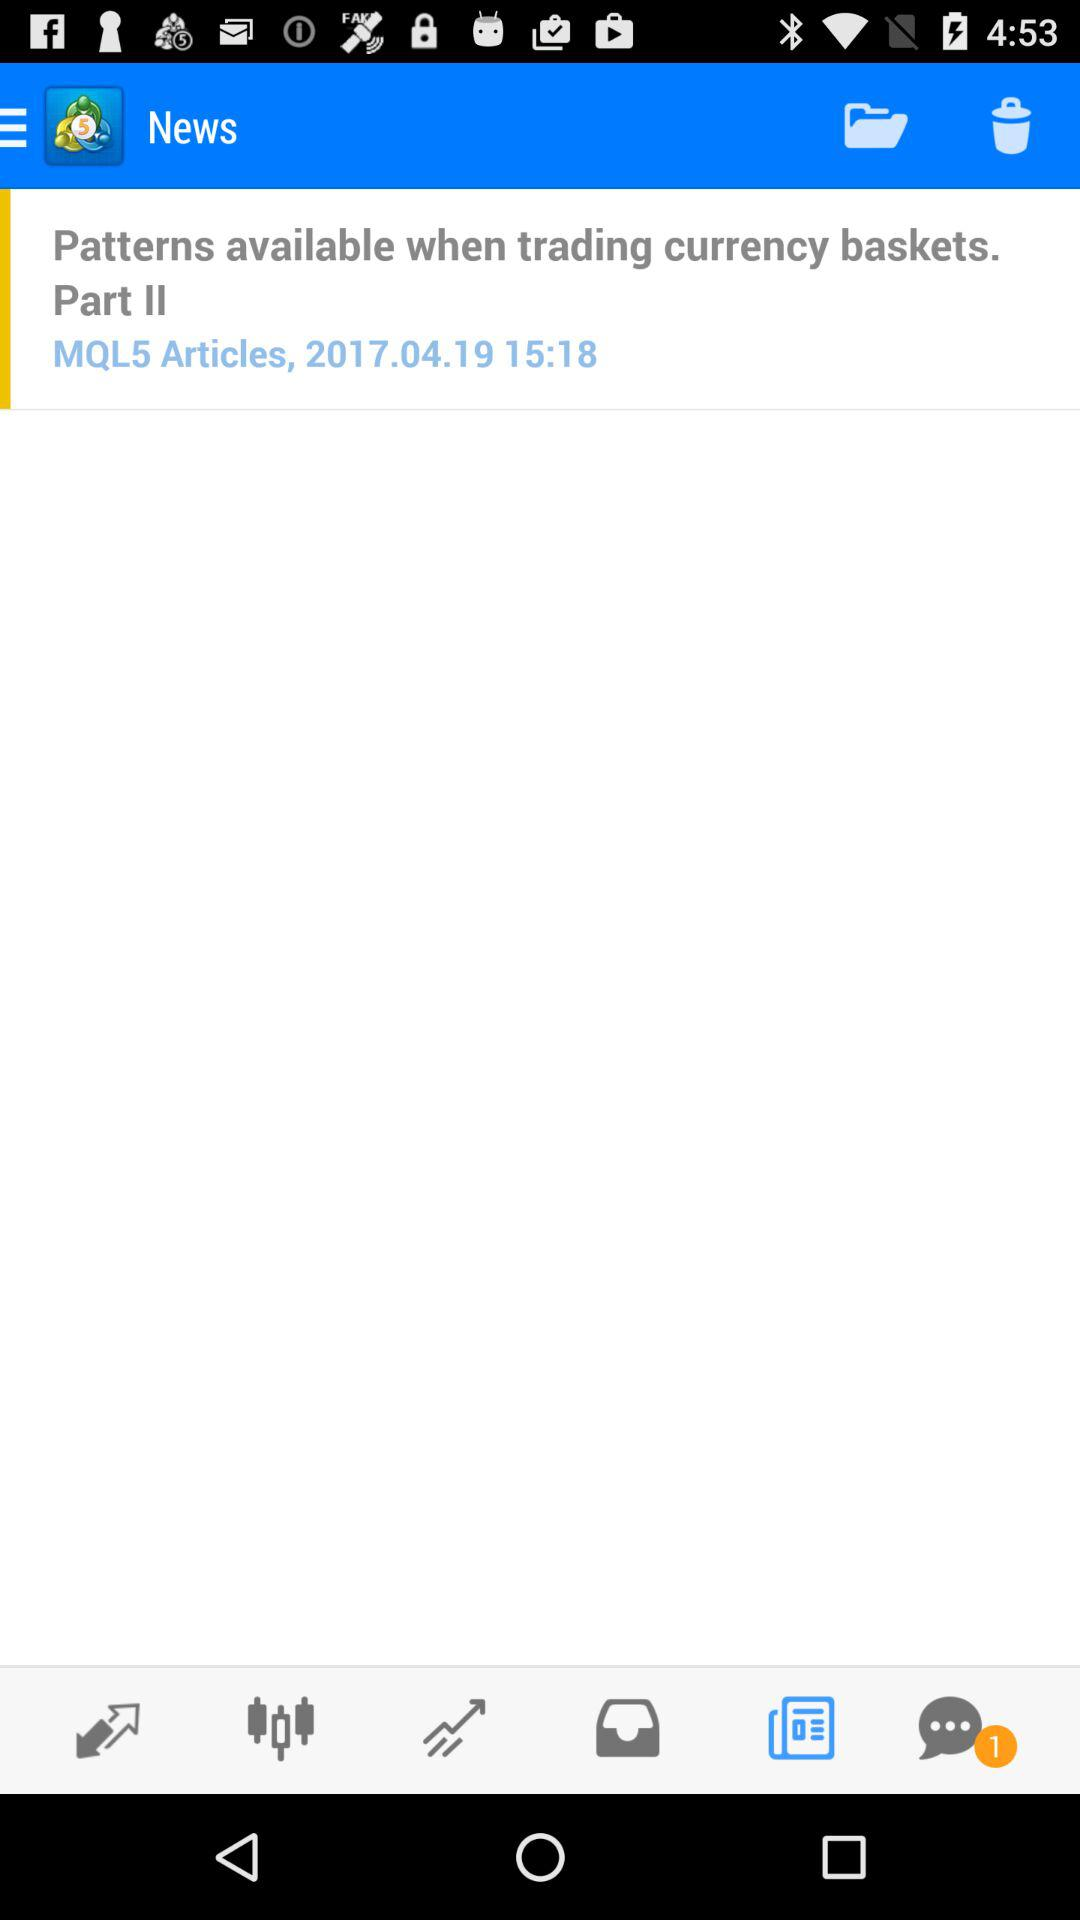Where is part 1 of the article saved?
When the provided information is insufficient, respond with <no answer>. <no answer> 